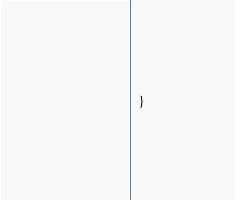<code> <loc_0><loc_0><loc_500><loc_500><_CSS_>  }</code> 